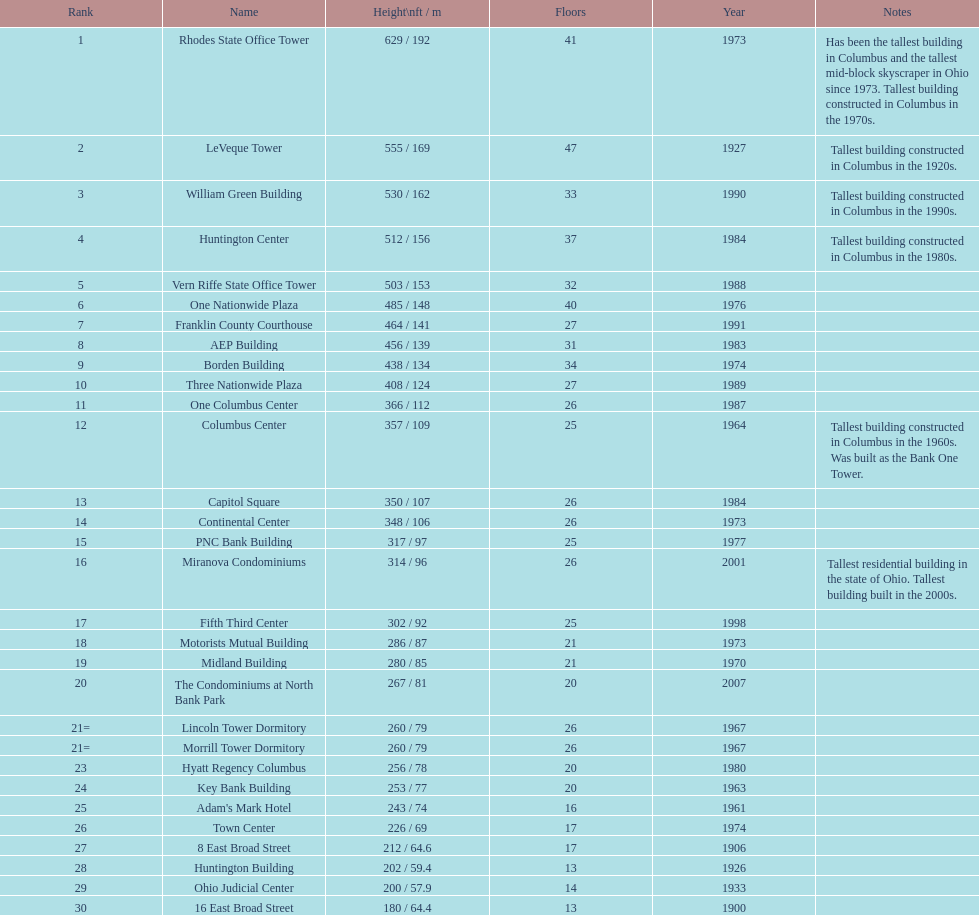What is the loftiest structure in columbus? Rhodes State Office Tower. 